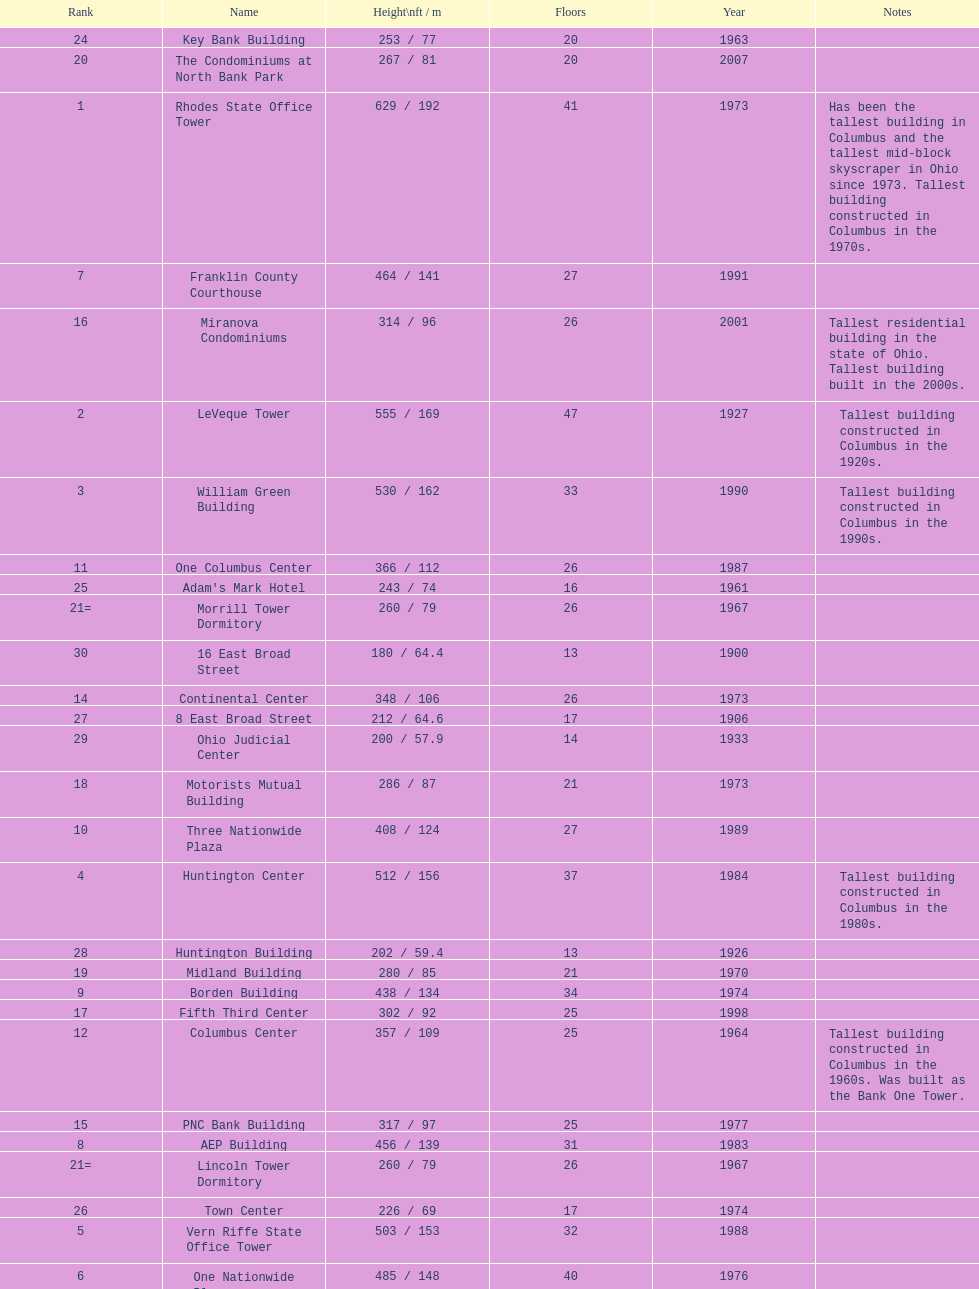How many buildings on this table are taller than 450 feet? 8. 